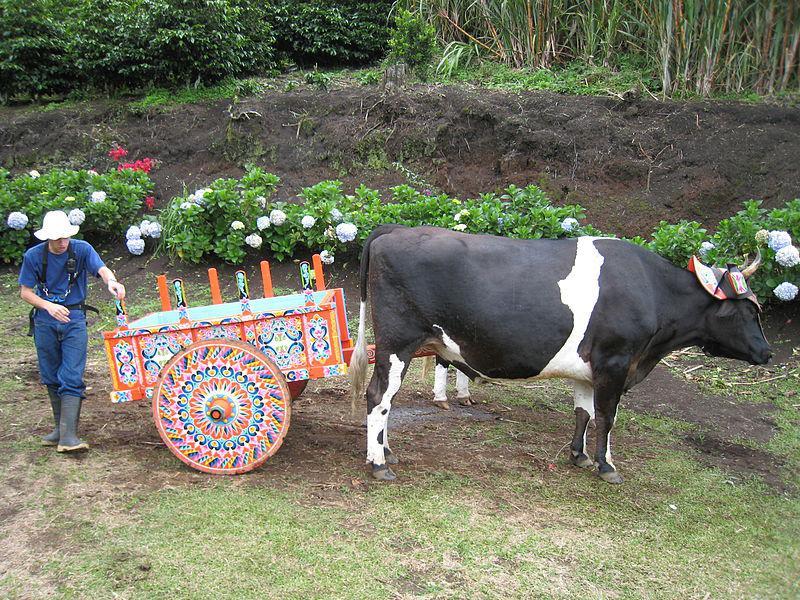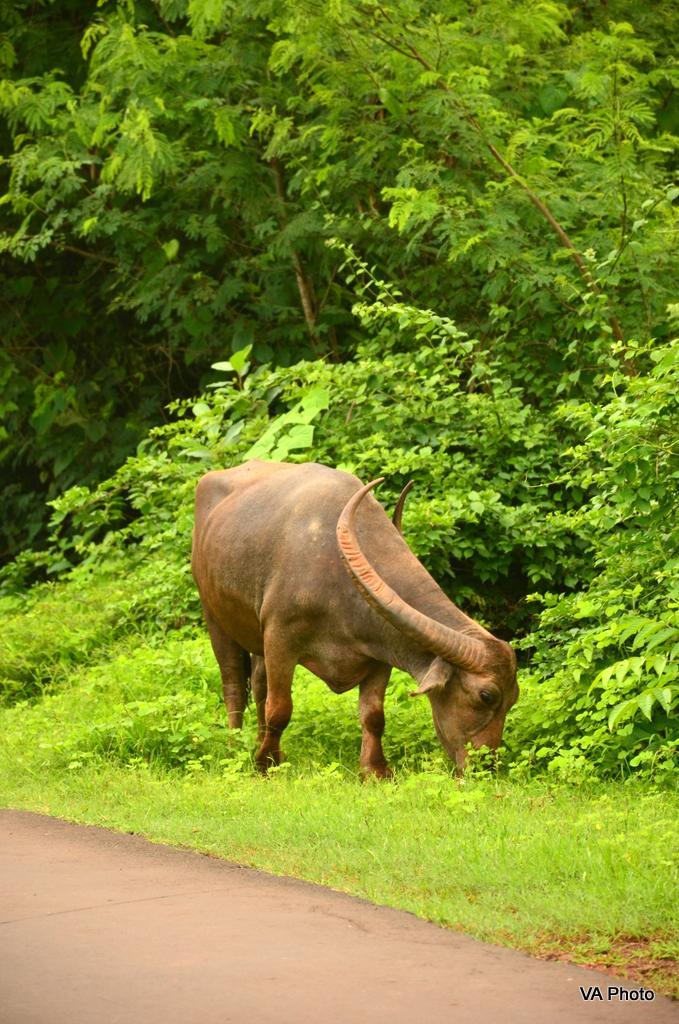The first image is the image on the left, the second image is the image on the right. Analyze the images presented: Is the assertion "a pair of oxen are pulling a cart down a dirt path" valid? Answer yes or no. No. The first image is the image on the left, the second image is the image on the right. Analyze the images presented: Is the assertion "The image on the right shows a single ox drawing a cart." valid? Answer yes or no. No. 